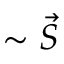<formula> <loc_0><loc_0><loc_500><loc_500>\sim \vec { S }</formula> 